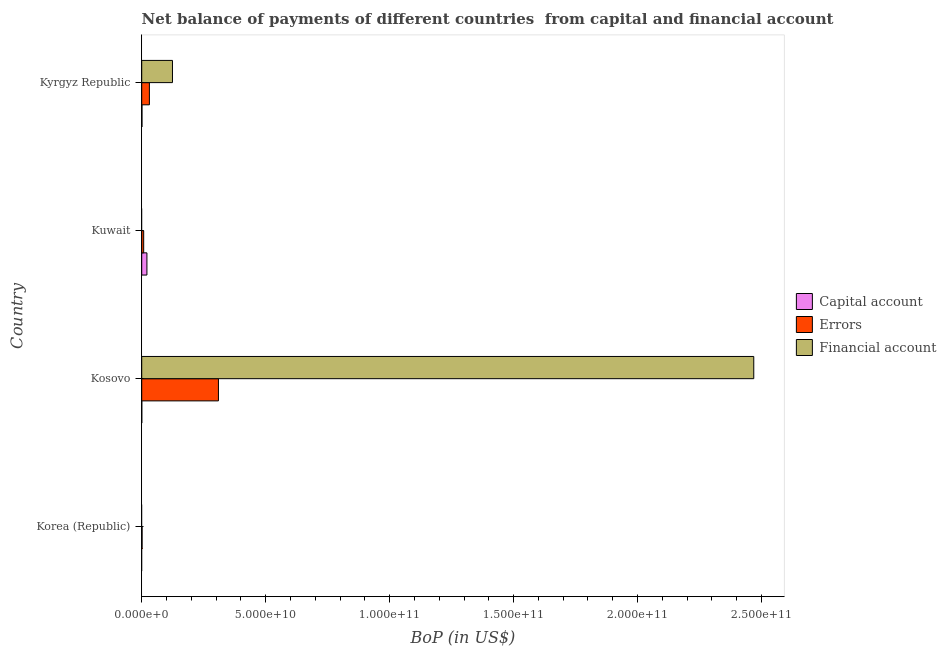How many bars are there on the 2nd tick from the top?
Your answer should be compact. 2. How many bars are there on the 3rd tick from the bottom?
Keep it short and to the point. 2. What is the amount of financial account in Korea (Republic)?
Provide a succinct answer. 0. Across all countries, what is the maximum amount of net capital account?
Make the answer very short. 2.10e+09. In which country was the amount of financial account maximum?
Make the answer very short. Kosovo. What is the total amount of financial account in the graph?
Offer a very short reply. 2.59e+11. What is the difference between the amount of errors in Korea (Republic) and that in Kuwait?
Offer a very short reply. -6.45e+08. What is the difference between the amount of errors in Kyrgyz Republic and the amount of financial account in Kosovo?
Ensure brevity in your answer.  -2.44e+11. What is the average amount of net capital account per country?
Make the answer very short. 5.58e+08. What is the difference between the amount of errors and amount of net capital account in Kyrgyz Republic?
Offer a terse response. 2.98e+09. In how many countries, is the amount of financial account greater than 50000000000 US$?
Your answer should be compact. 1. What is the ratio of the amount of errors in Kosovo to that in Kuwait?
Offer a terse response. 38.97. What is the difference between the highest and the second highest amount of net capital account?
Provide a short and direct response. 1.99e+09. What is the difference between the highest and the lowest amount of errors?
Your answer should be very brief. 3.08e+1. How many bars are there?
Offer a terse response. 9. Are all the bars in the graph horizontal?
Give a very brief answer. Yes. Does the graph contain any zero values?
Offer a terse response. Yes. Does the graph contain grids?
Offer a very short reply. No. Where does the legend appear in the graph?
Offer a very short reply. Center right. How many legend labels are there?
Your answer should be very brief. 3. What is the title of the graph?
Ensure brevity in your answer.  Net balance of payments of different countries  from capital and financial account. Does "Infant(female)" appear as one of the legend labels in the graph?
Your answer should be compact. No. What is the label or title of the X-axis?
Your answer should be very brief. BoP (in US$). What is the label or title of the Y-axis?
Ensure brevity in your answer.  Country. What is the BoP (in US$) of Capital account in Korea (Republic)?
Provide a short and direct response. 0. What is the BoP (in US$) in Errors in Korea (Republic)?
Ensure brevity in your answer.  1.49e+08. What is the BoP (in US$) in Capital account in Kosovo?
Provide a short and direct response. 2.67e+07. What is the BoP (in US$) in Errors in Kosovo?
Your answer should be very brief. 3.09e+1. What is the BoP (in US$) in Financial account in Kosovo?
Your answer should be compact. 2.47e+11. What is the BoP (in US$) of Capital account in Kuwait?
Keep it short and to the point. 2.10e+09. What is the BoP (in US$) of Errors in Kuwait?
Offer a terse response. 7.94e+08. What is the BoP (in US$) in Financial account in Kuwait?
Provide a short and direct response. 0. What is the BoP (in US$) in Capital account in Kyrgyz Republic?
Give a very brief answer. 1.09e+08. What is the BoP (in US$) of Errors in Kyrgyz Republic?
Your response must be concise. 3.09e+09. What is the BoP (in US$) in Financial account in Kyrgyz Republic?
Your answer should be compact. 1.24e+1. Across all countries, what is the maximum BoP (in US$) in Capital account?
Your answer should be compact. 2.10e+09. Across all countries, what is the maximum BoP (in US$) in Errors?
Your answer should be very brief. 3.09e+1. Across all countries, what is the maximum BoP (in US$) in Financial account?
Offer a terse response. 2.47e+11. Across all countries, what is the minimum BoP (in US$) in Errors?
Keep it short and to the point. 1.49e+08. Across all countries, what is the minimum BoP (in US$) in Financial account?
Keep it short and to the point. 0. What is the total BoP (in US$) in Capital account in the graph?
Keep it short and to the point. 2.23e+09. What is the total BoP (in US$) of Errors in the graph?
Offer a very short reply. 3.50e+1. What is the total BoP (in US$) in Financial account in the graph?
Your answer should be very brief. 2.59e+11. What is the difference between the BoP (in US$) in Errors in Korea (Republic) and that in Kosovo?
Your response must be concise. -3.08e+1. What is the difference between the BoP (in US$) of Errors in Korea (Republic) and that in Kuwait?
Ensure brevity in your answer.  -6.45e+08. What is the difference between the BoP (in US$) in Errors in Korea (Republic) and that in Kyrgyz Republic?
Keep it short and to the point. -2.94e+09. What is the difference between the BoP (in US$) in Capital account in Kosovo and that in Kuwait?
Offer a terse response. -2.07e+09. What is the difference between the BoP (in US$) of Errors in Kosovo and that in Kuwait?
Ensure brevity in your answer.  3.01e+1. What is the difference between the BoP (in US$) of Capital account in Kosovo and that in Kyrgyz Republic?
Offer a very short reply. -8.19e+07. What is the difference between the BoP (in US$) in Errors in Kosovo and that in Kyrgyz Republic?
Keep it short and to the point. 2.78e+1. What is the difference between the BoP (in US$) in Financial account in Kosovo and that in Kyrgyz Republic?
Provide a short and direct response. 2.34e+11. What is the difference between the BoP (in US$) of Capital account in Kuwait and that in Kyrgyz Republic?
Your response must be concise. 1.99e+09. What is the difference between the BoP (in US$) of Errors in Kuwait and that in Kyrgyz Republic?
Offer a terse response. -2.30e+09. What is the difference between the BoP (in US$) in Errors in Korea (Republic) and the BoP (in US$) in Financial account in Kosovo?
Make the answer very short. -2.47e+11. What is the difference between the BoP (in US$) in Errors in Korea (Republic) and the BoP (in US$) in Financial account in Kyrgyz Republic?
Give a very brief answer. -1.23e+1. What is the difference between the BoP (in US$) of Capital account in Kosovo and the BoP (in US$) of Errors in Kuwait?
Provide a succinct answer. -7.67e+08. What is the difference between the BoP (in US$) of Capital account in Kosovo and the BoP (in US$) of Errors in Kyrgyz Republic?
Ensure brevity in your answer.  -3.06e+09. What is the difference between the BoP (in US$) in Capital account in Kosovo and the BoP (in US$) in Financial account in Kyrgyz Republic?
Provide a succinct answer. -1.24e+1. What is the difference between the BoP (in US$) of Errors in Kosovo and the BoP (in US$) of Financial account in Kyrgyz Republic?
Keep it short and to the point. 1.85e+1. What is the difference between the BoP (in US$) of Capital account in Kuwait and the BoP (in US$) of Errors in Kyrgyz Republic?
Your answer should be very brief. -9.94e+08. What is the difference between the BoP (in US$) in Capital account in Kuwait and the BoP (in US$) in Financial account in Kyrgyz Republic?
Provide a short and direct response. -1.03e+1. What is the difference between the BoP (in US$) of Errors in Kuwait and the BoP (in US$) of Financial account in Kyrgyz Republic?
Make the answer very short. -1.16e+1. What is the average BoP (in US$) in Capital account per country?
Ensure brevity in your answer.  5.58e+08. What is the average BoP (in US$) in Errors per country?
Your answer should be compact. 8.74e+09. What is the average BoP (in US$) of Financial account per country?
Your answer should be very brief. 6.48e+1. What is the difference between the BoP (in US$) of Capital account and BoP (in US$) of Errors in Kosovo?
Give a very brief answer. -3.09e+1. What is the difference between the BoP (in US$) of Capital account and BoP (in US$) of Financial account in Kosovo?
Make the answer very short. -2.47e+11. What is the difference between the BoP (in US$) in Errors and BoP (in US$) in Financial account in Kosovo?
Provide a succinct answer. -2.16e+11. What is the difference between the BoP (in US$) of Capital account and BoP (in US$) of Errors in Kuwait?
Offer a very short reply. 1.30e+09. What is the difference between the BoP (in US$) in Capital account and BoP (in US$) in Errors in Kyrgyz Republic?
Offer a very short reply. -2.98e+09. What is the difference between the BoP (in US$) in Capital account and BoP (in US$) in Financial account in Kyrgyz Republic?
Your answer should be very brief. -1.23e+1. What is the difference between the BoP (in US$) in Errors and BoP (in US$) in Financial account in Kyrgyz Republic?
Offer a terse response. -9.31e+09. What is the ratio of the BoP (in US$) in Errors in Korea (Republic) to that in Kosovo?
Make the answer very short. 0. What is the ratio of the BoP (in US$) of Errors in Korea (Republic) to that in Kuwait?
Give a very brief answer. 0.19. What is the ratio of the BoP (in US$) in Errors in Korea (Republic) to that in Kyrgyz Republic?
Your response must be concise. 0.05. What is the ratio of the BoP (in US$) of Capital account in Kosovo to that in Kuwait?
Give a very brief answer. 0.01. What is the ratio of the BoP (in US$) in Errors in Kosovo to that in Kuwait?
Offer a very short reply. 38.97. What is the ratio of the BoP (in US$) of Capital account in Kosovo to that in Kyrgyz Republic?
Your response must be concise. 0.25. What is the ratio of the BoP (in US$) of Errors in Kosovo to that in Kyrgyz Republic?
Keep it short and to the point. 10.01. What is the ratio of the BoP (in US$) of Financial account in Kosovo to that in Kyrgyz Republic?
Give a very brief answer. 19.91. What is the ratio of the BoP (in US$) of Capital account in Kuwait to that in Kyrgyz Republic?
Provide a short and direct response. 19.31. What is the ratio of the BoP (in US$) of Errors in Kuwait to that in Kyrgyz Republic?
Provide a succinct answer. 0.26. What is the difference between the highest and the second highest BoP (in US$) of Capital account?
Provide a succinct answer. 1.99e+09. What is the difference between the highest and the second highest BoP (in US$) of Errors?
Make the answer very short. 2.78e+1. What is the difference between the highest and the lowest BoP (in US$) of Capital account?
Provide a short and direct response. 2.10e+09. What is the difference between the highest and the lowest BoP (in US$) of Errors?
Provide a succinct answer. 3.08e+1. What is the difference between the highest and the lowest BoP (in US$) of Financial account?
Give a very brief answer. 2.47e+11. 